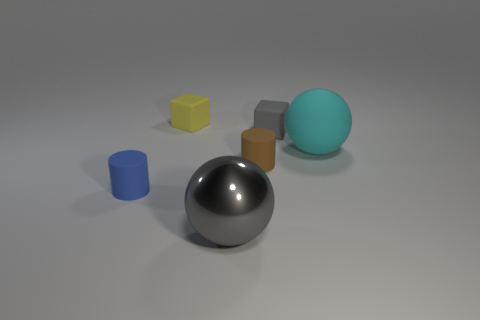Add 3 small rubber things. How many objects exist? 9 Subtract all blocks. How many objects are left? 4 Add 4 big cyan matte spheres. How many big cyan matte spheres exist? 5 Subtract 0 green cylinders. How many objects are left? 6 Subtract all small cylinders. Subtract all small blocks. How many objects are left? 2 Add 2 small brown objects. How many small brown objects are left? 3 